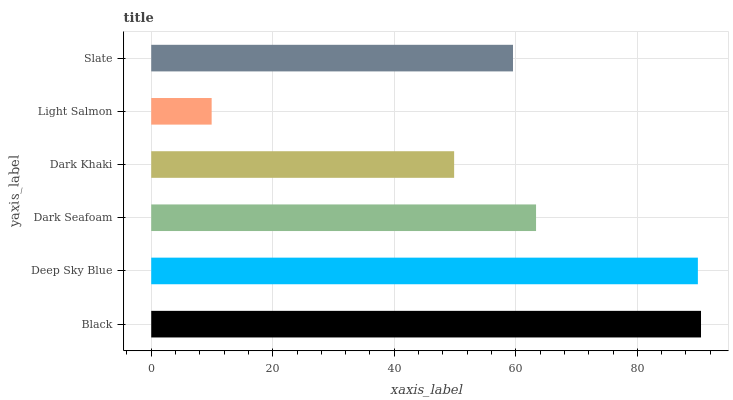Is Light Salmon the minimum?
Answer yes or no. Yes. Is Black the maximum?
Answer yes or no. Yes. Is Deep Sky Blue the minimum?
Answer yes or no. No. Is Deep Sky Blue the maximum?
Answer yes or no. No. Is Black greater than Deep Sky Blue?
Answer yes or no. Yes. Is Deep Sky Blue less than Black?
Answer yes or no. Yes. Is Deep Sky Blue greater than Black?
Answer yes or no. No. Is Black less than Deep Sky Blue?
Answer yes or no. No. Is Dark Seafoam the high median?
Answer yes or no. Yes. Is Slate the low median?
Answer yes or no. Yes. Is Light Salmon the high median?
Answer yes or no. No. Is Light Salmon the low median?
Answer yes or no. No. 